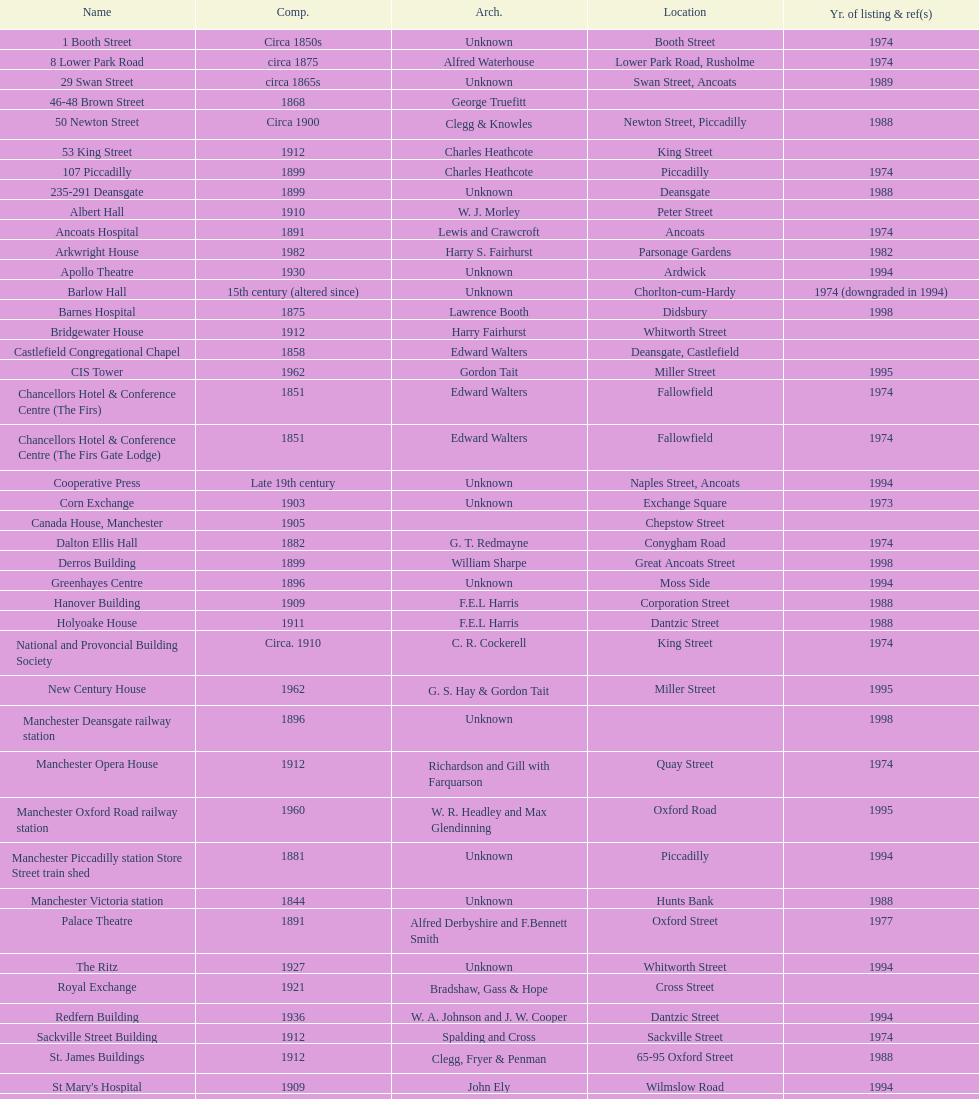How many buildings had alfred waterhouse as their architect? 3. 